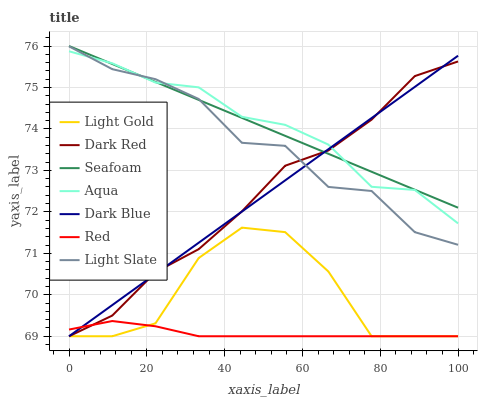Does Red have the minimum area under the curve?
Answer yes or no. Yes. Does Aqua have the maximum area under the curve?
Answer yes or no. Yes. Does Dark Red have the minimum area under the curve?
Answer yes or no. No. Does Dark Red have the maximum area under the curve?
Answer yes or no. No. Is Seafoam the smoothest?
Answer yes or no. Yes. Is Light Gold the roughest?
Answer yes or no. Yes. Is Dark Red the smoothest?
Answer yes or no. No. Is Dark Red the roughest?
Answer yes or no. No. Does Aqua have the lowest value?
Answer yes or no. No. Does Seafoam have the highest value?
Answer yes or no. Yes. Does Dark Red have the highest value?
Answer yes or no. No. Is Light Gold less than Light Slate?
Answer yes or no. Yes. Is Light Slate greater than Red?
Answer yes or no. Yes. Does Dark Red intersect Dark Blue?
Answer yes or no. Yes. Is Dark Red less than Dark Blue?
Answer yes or no. No. Is Dark Red greater than Dark Blue?
Answer yes or no. No. Does Light Gold intersect Light Slate?
Answer yes or no. No. 